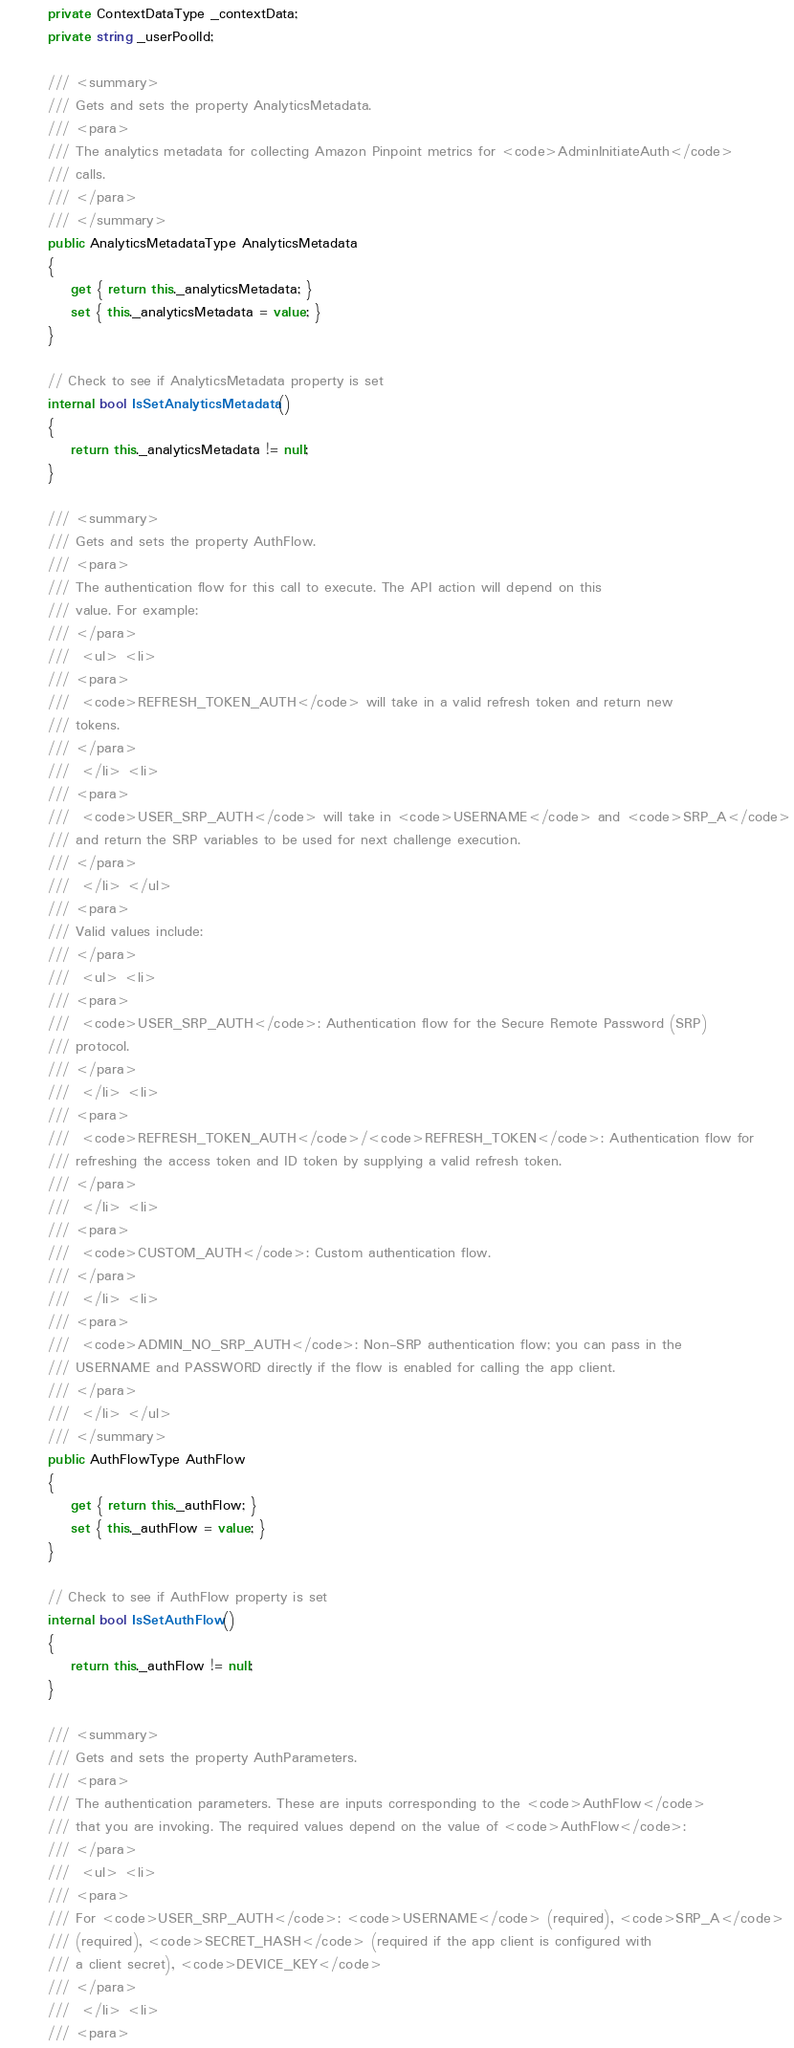Convert code to text. <code><loc_0><loc_0><loc_500><loc_500><_C#_>        private ContextDataType _contextData;
        private string _userPoolId;

        /// <summary>
        /// Gets and sets the property AnalyticsMetadata. 
        /// <para>
        /// The analytics metadata for collecting Amazon Pinpoint metrics for <code>AdminInitiateAuth</code>
        /// calls.
        /// </para>
        /// </summary>
        public AnalyticsMetadataType AnalyticsMetadata
        {
            get { return this._analyticsMetadata; }
            set { this._analyticsMetadata = value; }
        }

        // Check to see if AnalyticsMetadata property is set
        internal bool IsSetAnalyticsMetadata()
        {
            return this._analyticsMetadata != null;
        }

        /// <summary>
        /// Gets and sets the property AuthFlow. 
        /// <para>
        /// The authentication flow for this call to execute. The API action will depend on this
        /// value. For example:
        /// </para>
        ///  <ul> <li> 
        /// <para>
        ///  <code>REFRESH_TOKEN_AUTH</code> will take in a valid refresh token and return new
        /// tokens.
        /// </para>
        ///  </li> <li> 
        /// <para>
        ///  <code>USER_SRP_AUTH</code> will take in <code>USERNAME</code> and <code>SRP_A</code>
        /// and return the SRP variables to be used for next challenge execution.
        /// </para>
        ///  </li> </ul> 
        /// <para>
        /// Valid values include:
        /// </para>
        ///  <ul> <li> 
        /// <para>
        ///  <code>USER_SRP_AUTH</code>: Authentication flow for the Secure Remote Password (SRP)
        /// protocol.
        /// </para>
        ///  </li> <li> 
        /// <para>
        ///  <code>REFRESH_TOKEN_AUTH</code>/<code>REFRESH_TOKEN</code>: Authentication flow for
        /// refreshing the access token and ID token by supplying a valid refresh token.
        /// </para>
        ///  </li> <li> 
        /// <para>
        ///  <code>CUSTOM_AUTH</code>: Custom authentication flow.
        /// </para>
        ///  </li> <li> 
        /// <para>
        ///  <code>ADMIN_NO_SRP_AUTH</code>: Non-SRP authentication flow; you can pass in the
        /// USERNAME and PASSWORD directly if the flow is enabled for calling the app client.
        /// </para>
        ///  </li> </ul>
        /// </summary>
        public AuthFlowType AuthFlow
        {
            get { return this._authFlow; }
            set { this._authFlow = value; }
        }

        // Check to see if AuthFlow property is set
        internal bool IsSetAuthFlow()
        {
            return this._authFlow != null;
        }

        /// <summary>
        /// Gets and sets the property AuthParameters. 
        /// <para>
        /// The authentication parameters. These are inputs corresponding to the <code>AuthFlow</code>
        /// that you are invoking. The required values depend on the value of <code>AuthFlow</code>:
        /// </para>
        ///  <ul> <li> 
        /// <para>
        /// For <code>USER_SRP_AUTH</code>: <code>USERNAME</code> (required), <code>SRP_A</code>
        /// (required), <code>SECRET_HASH</code> (required if the app client is configured with
        /// a client secret), <code>DEVICE_KEY</code> 
        /// </para>
        ///  </li> <li> 
        /// <para></code> 